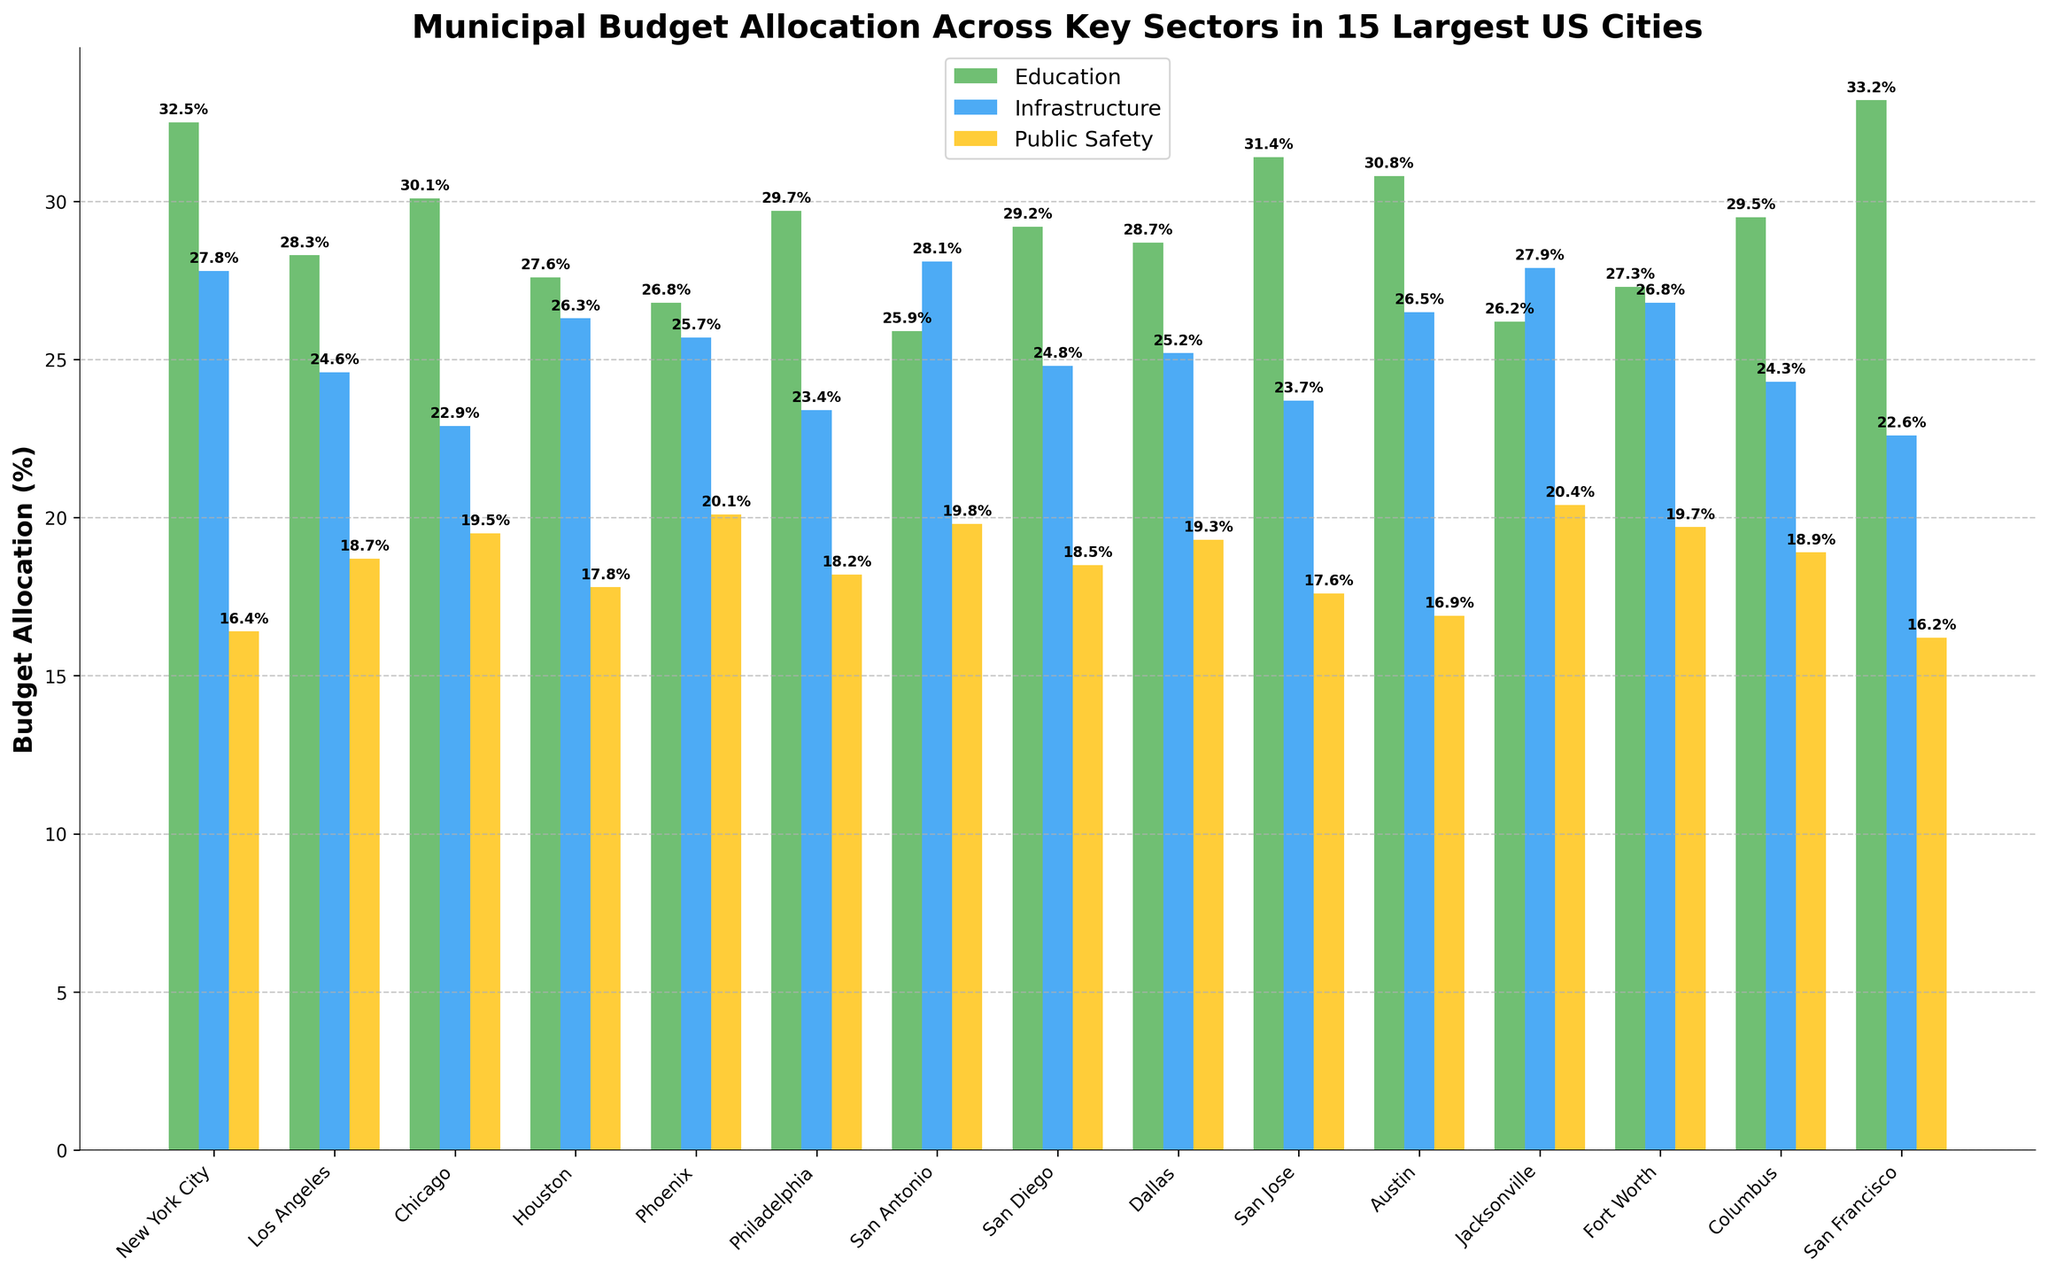What's the highest budget allocation percentage for Education among the cities? The tallest green bar represents the highest budget allocation percentage for Education. By comparing all the green bars, the tallest one belongs to San Francisco with 33.2%.
Answer: 33.2% Which city allocates the least percentage of its budget to Infrastructure? The shortest blue bar indicates the least budget allocation to Infrastructure. By examining all blue bars, the shortest one is in San Francisco with 22.6%.
Answer: San Francisco What's the combined budget allocation for Education and Public Safety in Chicago? Add the heights of the green and yellow bars for Education and Public Safety in Chicago. The values are 30.1% (Education) + 19.5% (Public Safety), totaling 49.6%.
Answer: 49.6% Which city has the greatest difference between Education and Public Safety budget allocations? Determine the difference between the heights of the green and yellow bars for each city. The greatest difference is in New York City, with the values being 32.5% (Education) - 16.4% (Public Safety) = 16.1%.
Answer: New York City What is the average budget allocation percentage for Infrastructure across all cities? Sum the heights of all the blue bars for Infrastructure and divide by the number of cities. The totals sum up to 365.6%. Divided by 15 cities, the average is approximately 24.37%.
Answer: 24.37% Which two cities allocate an equal percentage of their budgets to Public Safety? Check for cities where the yellow bars are of equal height. Dallas and Columbus both allocate 19.3% to Public Safety, as their yellow bars are of the same height.
Answer: Dallas and Columbus Is the budget allocation for Education in Los Angeles greater than that in Phoenix? Compare the heights of the green bars for Los Angeles and Phoenix. Los Angeles allocates 28.3%, which is greater than Phoenix's 26.8%.
Answer: Yes What is the difference in Infrastructure budget allocation between San Antonio and Jacksonville? Subtract the height of the blue bar for Infrastructure in Jacksonville from that in San Antonio. The values are 28.1% (San Antonio) - 27.9% (Jacksonville), giving a difference of 0.2%.
Answer: 0.2% Which city allocates more of its budget to Public Safety than Education? Look for cities where the yellow bar is taller than the green bar. Phoenix is the city with Public Safety allocation (20.1%) greater than Education (26.8%).
Answer: Phoenix 